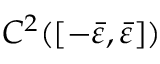<formula> <loc_0><loc_0><loc_500><loc_500>C ^ { 2 } ( [ - \bar { \varepsilon } , \bar { \varepsilon } ] )</formula> 